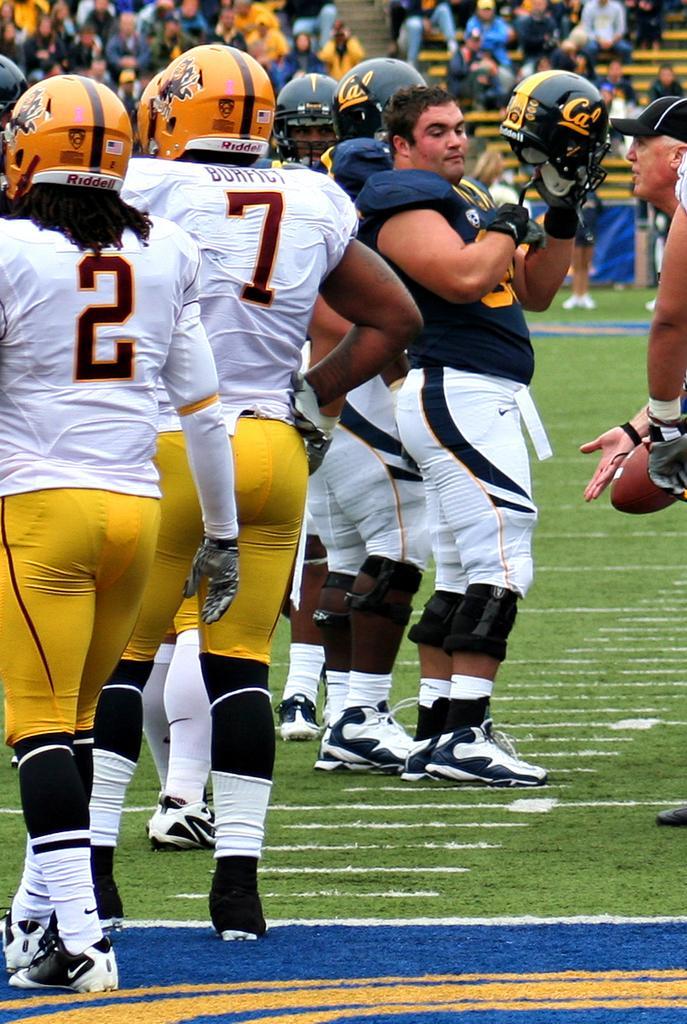In one or two sentences, can you explain what this image depicts? Here we can see few persons on the ground and this is grass. In the background we can see crowd. 